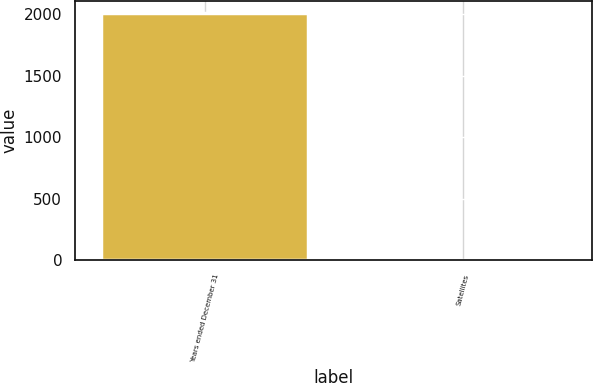Convert chart. <chart><loc_0><loc_0><loc_500><loc_500><bar_chart><fcel>Years ended December 31<fcel>Satellites<nl><fcel>2006<fcel>4<nl></chart> 